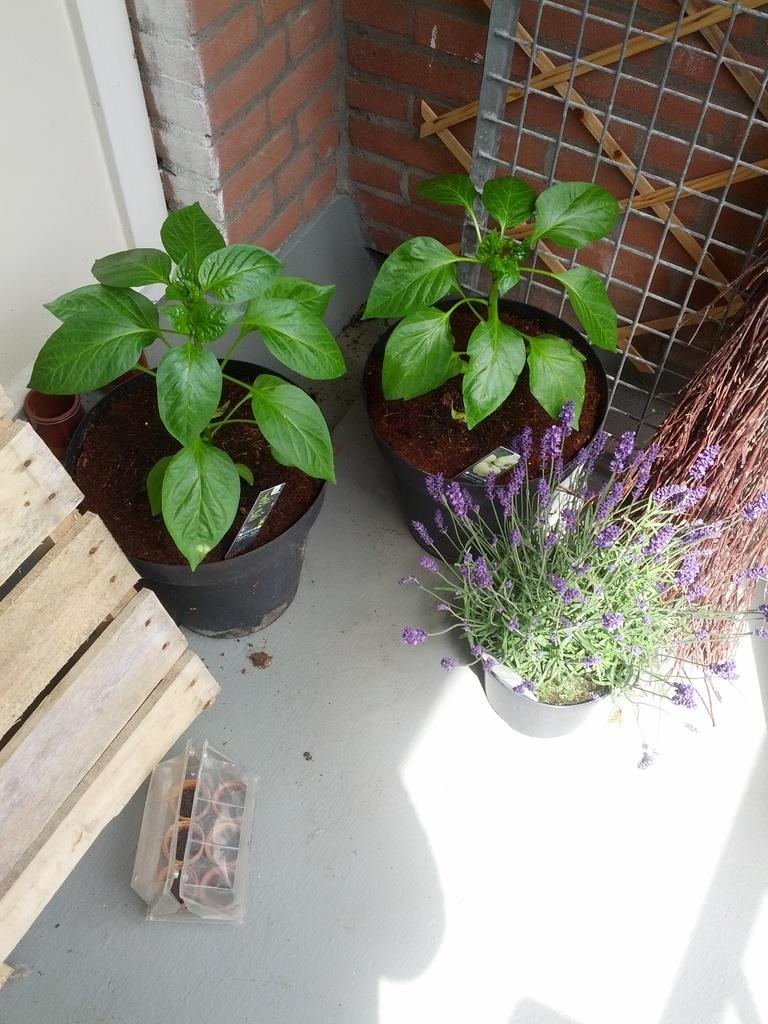What type of containers are visible in the image? The plant pots are visible in the image. Can you describe the object in the left corner of the image? There is a wooden object in the left corner of the image. What type of structure can be seen in the background of the image? There is a brick wall in the background of the image. How many spiders are crawling on the plant pots in the image? There are no spiders visible in the image; it only shows plant pots and a wooden object. 